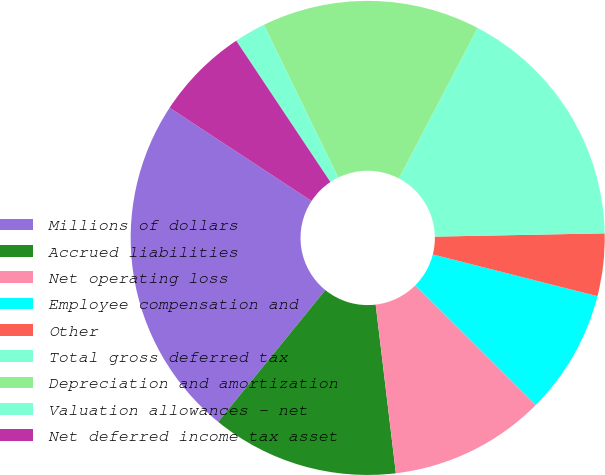Convert chart to OTSL. <chart><loc_0><loc_0><loc_500><loc_500><pie_chart><fcel>Millions of dollars<fcel>Accrued liabilities<fcel>Net operating loss<fcel>Employee compensation and<fcel>Other<fcel>Total gross deferred tax<fcel>Depreciation and amortization<fcel>Valuation allowances - net<fcel>Net deferred income tax asset<nl><fcel>23.39%<fcel>12.76%<fcel>10.64%<fcel>8.51%<fcel>4.26%<fcel>17.02%<fcel>14.89%<fcel>2.14%<fcel>6.39%<nl></chart> 